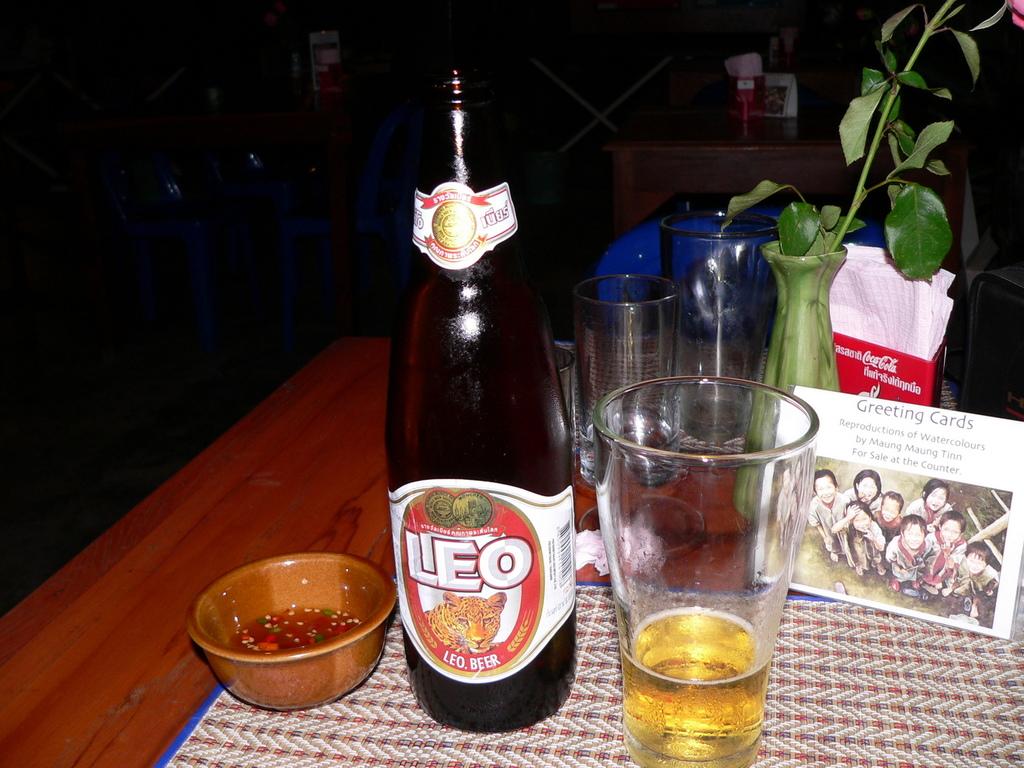What's the name of that beer?
Ensure brevity in your answer.  Leo. What type of cards are mentioned in the card with the photo?
Make the answer very short. Greeting cards. 